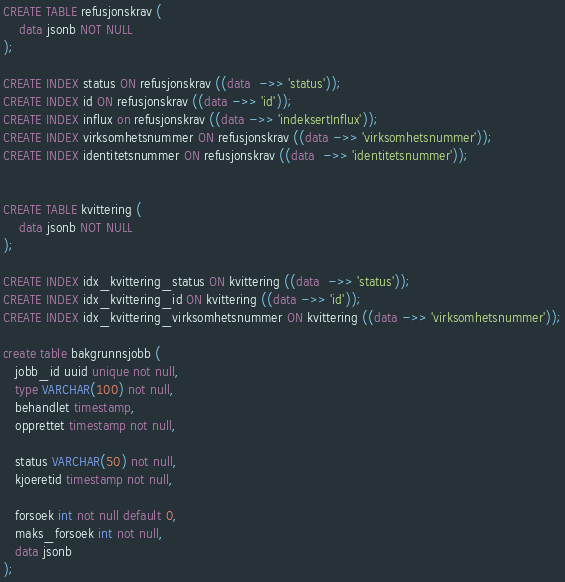Convert code to text. <code><loc_0><loc_0><loc_500><loc_500><_SQL_>CREATE TABLE refusjonskrav (
    data jsonb NOT NULL
);

CREATE INDEX status ON refusjonskrav ((data  ->> 'status'));
CREATE INDEX id ON refusjonskrav ((data ->> 'id'));
CREATE INDEX influx on refusjonskrav ((data ->> 'indeksertInflux'));
CREATE INDEX virksomhetsnummer ON refusjonskrav ((data ->> 'virksomhetsnummer'));
CREATE INDEX identitetsnummer ON refusjonskrav ((data  ->> 'identitetsnummer'));


CREATE TABLE kvittering (
    data jsonb NOT NULL
);

CREATE INDEX idx_kvittering_status ON kvittering ((data  ->> 'status'));
CREATE INDEX idx_kvittering_id ON kvittering ((data ->> 'id'));
CREATE INDEX idx_kvittering_virksomhetsnummer ON kvittering ((data ->> 'virksomhetsnummer'));

create table bakgrunnsjobb (
   jobb_id uuid unique not null,
   type VARCHAR(100) not null,
   behandlet timestamp,
   opprettet timestamp not null,

   status VARCHAR(50) not null,
   kjoeretid timestamp not null,

   forsoek int not null default 0,
   maks_forsoek int not null,
   data jsonb
);</code> 